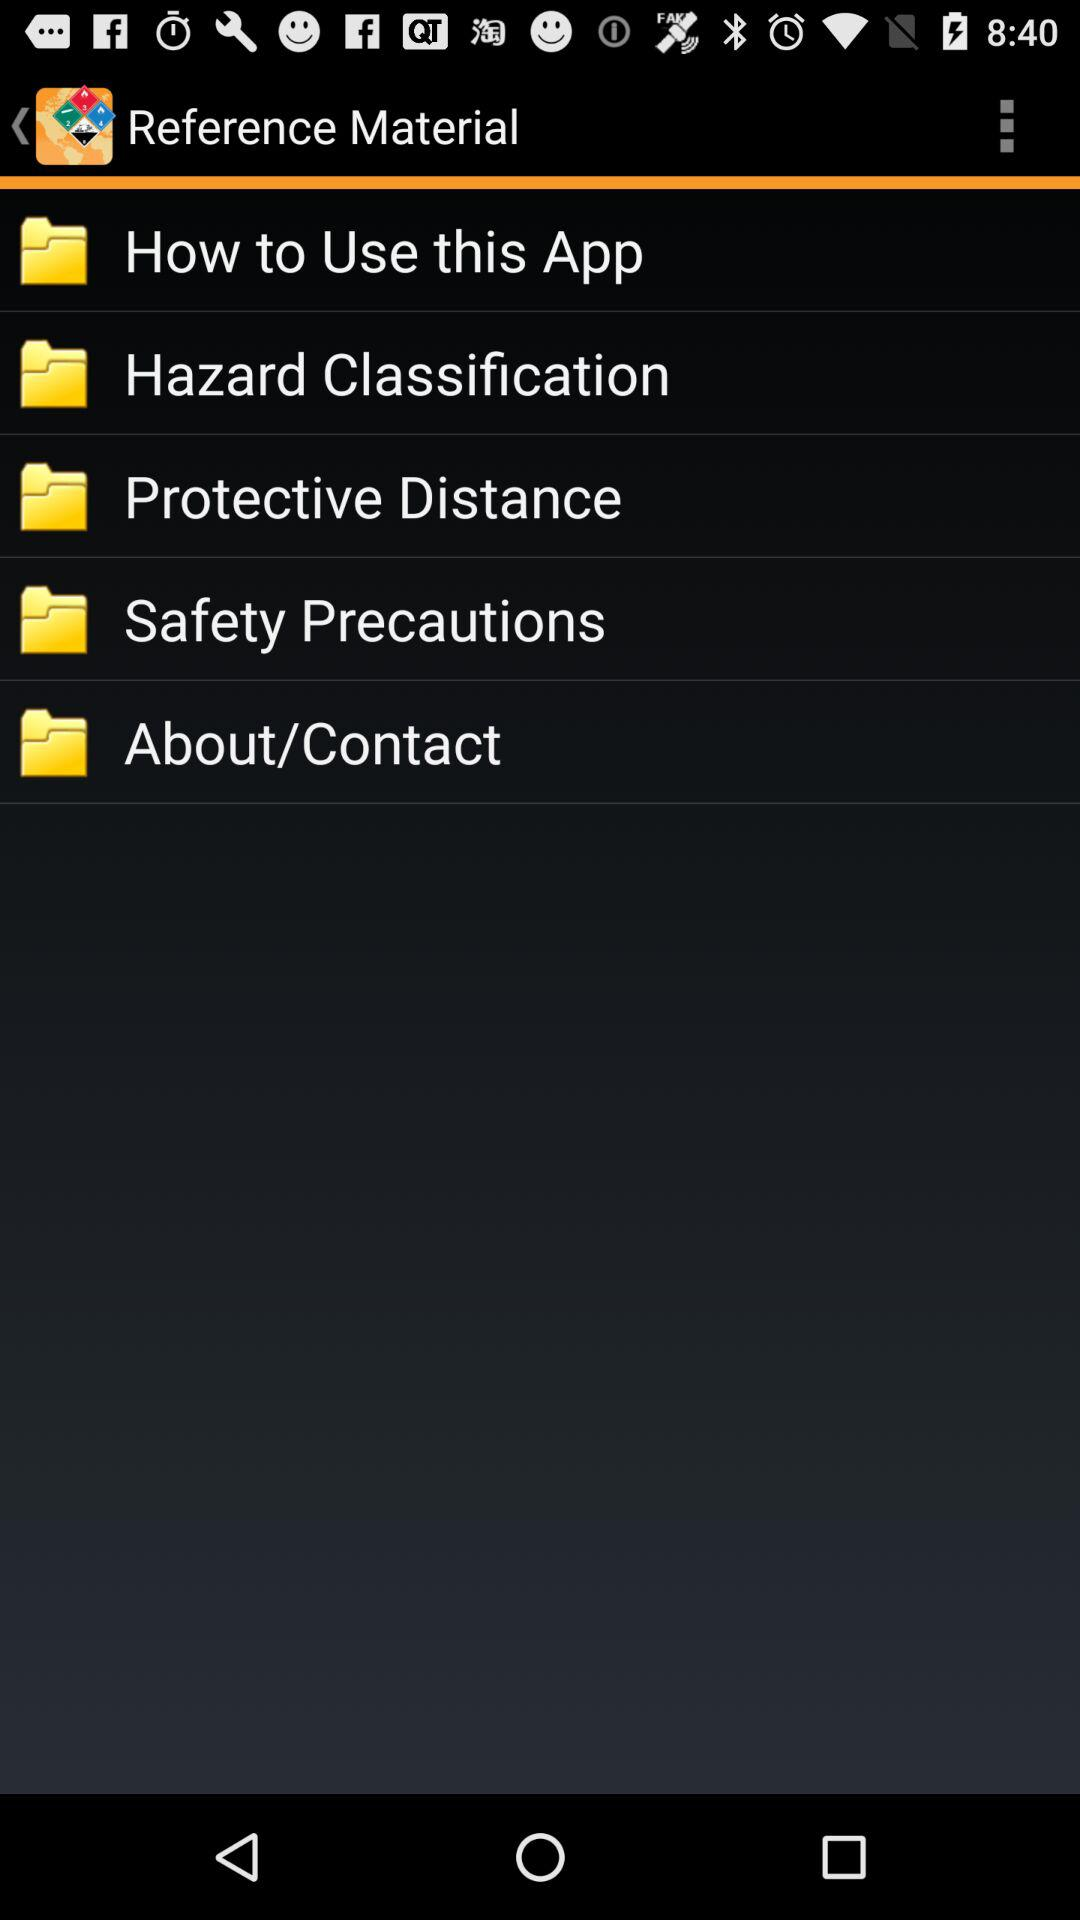What is the name of the application? The name of the application is "Reference Material". 